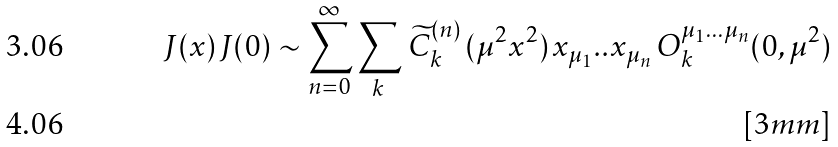<formula> <loc_0><loc_0><loc_500><loc_500>J ( x ) \, J ( 0 ) \sim \sum ^ { \infty } _ { n = 0 } \sum _ { k } \, \widetilde { C } ^ { ( n ) } _ { k } \, ( \mu ^ { 2 } x ^ { 2 } ) \, x _ { \mu { _ { 1 } } } . . x _ { \mu { _ { n } } } \, O _ { k } ^ { \mu _ { 1 } \dots \mu _ { n } } ( 0 , \mu ^ { 2 } ) \\ [ 3 m m ]</formula> 